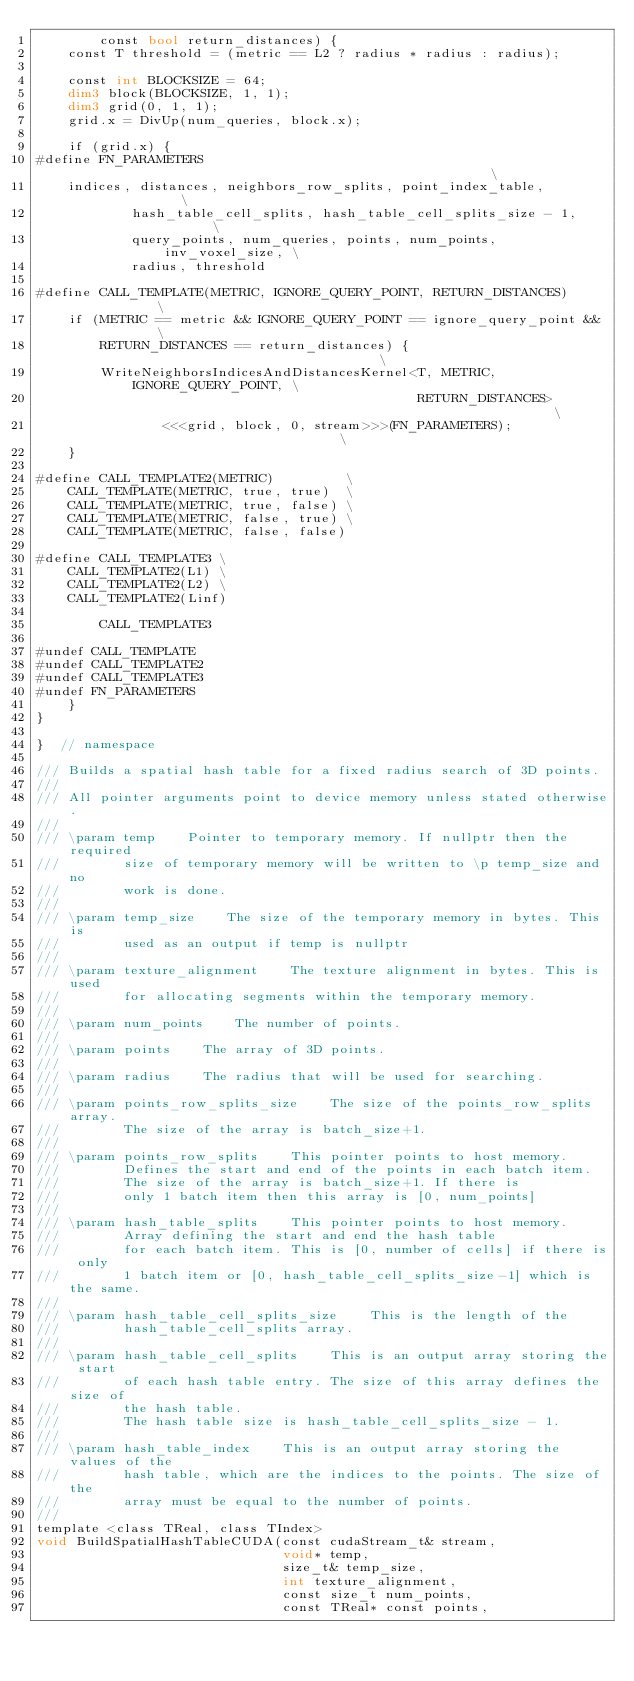Convert code to text. <code><loc_0><loc_0><loc_500><loc_500><_Cuda_>        const bool return_distances) {
    const T threshold = (metric == L2 ? radius * radius : radius);

    const int BLOCKSIZE = 64;
    dim3 block(BLOCKSIZE, 1, 1);
    dim3 grid(0, 1, 1);
    grid.x = DivUp(num_queries, block.x);

    if (grid.x) {
#define FN_PARAMETERS                                                      \
    indices, distances, neighbors_row_splits, point_index_table,           \
            hash_table_cell_splits, hash_table_cell_splits_size - 1,       \
            query_points, num_queries, points, num_points, inv_voxel_size, \
            radius, threshold

#define CALL_TEMPLATE(METRIC, IGNORE_QUERY_POINT, RETURN_DISTANCES)            \
    if (METRIC == metric && IGNORE_QUERY_POINT == ignore_query_point &&        \
        RETURN_DISTANCES == return_distances) {                                \
        WriteNeighborsIndicesAndDistancesKernel<T, METRIC, IGNORE_QUERY_POINT, \
                                                RETURN_DISTANCES>              \
                <<<grid, block, 0, stream>>>(FN_PARAMETERS);                   \
    }

#define CALL_TEMPLATE2(METRIC)         \
    CALL_TEMPLATE(METRIC, true, true)  \
    CALL_TEMPLATE(METRIC, true, false) \
    CALL_TEMPLATE(METRIC, false, true) \
    CALL_TEMPLATE(METRIC, false, false)

#define CALL_TEMPLATE3 \
    CALL_TEMPLATE2(L1) \
    CALL_TEMPLATE2(L2) \
    CALL_TEMPLATE2(Linf)

        CALL_TEMPLATE3

#undef CALL_TEMPLATE
#undef CALL_TEMPLATE2
#undef CALL_TEMPLATE3
#undef FN_PARAMETERS
    }
}

}  // namespace

/// Builds a spatial hash table for a fixed radius search of 3D points.
///
/// All pointer arguments point to device memory unless stated otherwise.
///
/// \param temp    Pointer to temporary memory. If nullptr then the required
///        size of temporary memory will be written to \p temp_size and no
///        work is done.
///
/// \param temp_size    The size of the temporary memory in bytes. This is
///        used as an output if temp is nullptr
///
/// \param texture_alignment    The texture alignment in bytes. This is used
///        for allocating segments within the temporary memory.
///
/// \param num_points    The number of points.
///
/// \param points    The array of 3D points.
///
/// \param radius    The radius that will be used for searching.
///
/// \param points_row_splits_size    The size of the points_row_splits array.
///        The size of the array is batch_size+1.
///
/// \param points_row_splits    This pointer points to host memory.
///        Defines the start and end of the points in each batch item.
///        The size of the array is batch_size+1. If there is
///        only 1 batch item then this array is [0, num_points]
///
/// \param hash_table_splits    This pointer points to host memory.
///        Array defining the start and end the hash table
///        for each batch item. This is [0, number of cells] if there is only
///        1 batch item or [0, hash_table_cell_splits_size-1] which is the same.
///
/// \param hash_table_cell_splits_size    This is the length of the
///        hash_table_cell_splits array.
///
/// \param hash_table_cell_splits    This is an output array storing the start
///        of each hash table entry. The size of this array defines the size of
///        the hash table.
///        The hash table size is hash_table_cell_splits_size - 1.
///
/// \param hash_table_index    This is an output array storing the values of the
///        hash table, which are the indices to the points. The size of the
///        array must be equal to the number of points.
///
template <class TReal, class TIndex>
void BuildSpatialHashTableCUDA(const cudaStream_t& stream,
                               void* temp,
                               size_t& temp_size,
                               int texture_alignment,
                               const size_t num_points,
                               const TReal* const points,</code> 